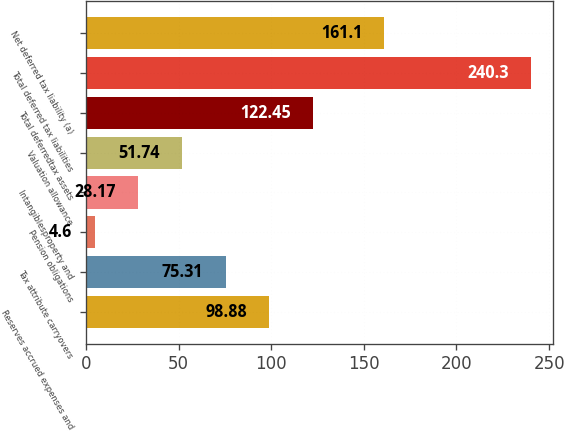Convert chart. <chart><loc_0><loc_0><loc_500><loc_500><bar_chart><fcel>Reserves accrued expenses and<fcel>Tax attribute carryovers<fcel>Pension obligations<fcel>Intangiblesproperty and<fcel>Valuation allowance<fcel>Total deferredtax assets<fcel>Total deferred tax liabilities<fcel>Net deferred tax liability (a)<nl><fcel>98.88<fcel>75.31<fcel>4.6<fcel>28.17<fcel>51.74<fcel>122.45<fcel>240.3<fcel>161.1<nl></chart> 